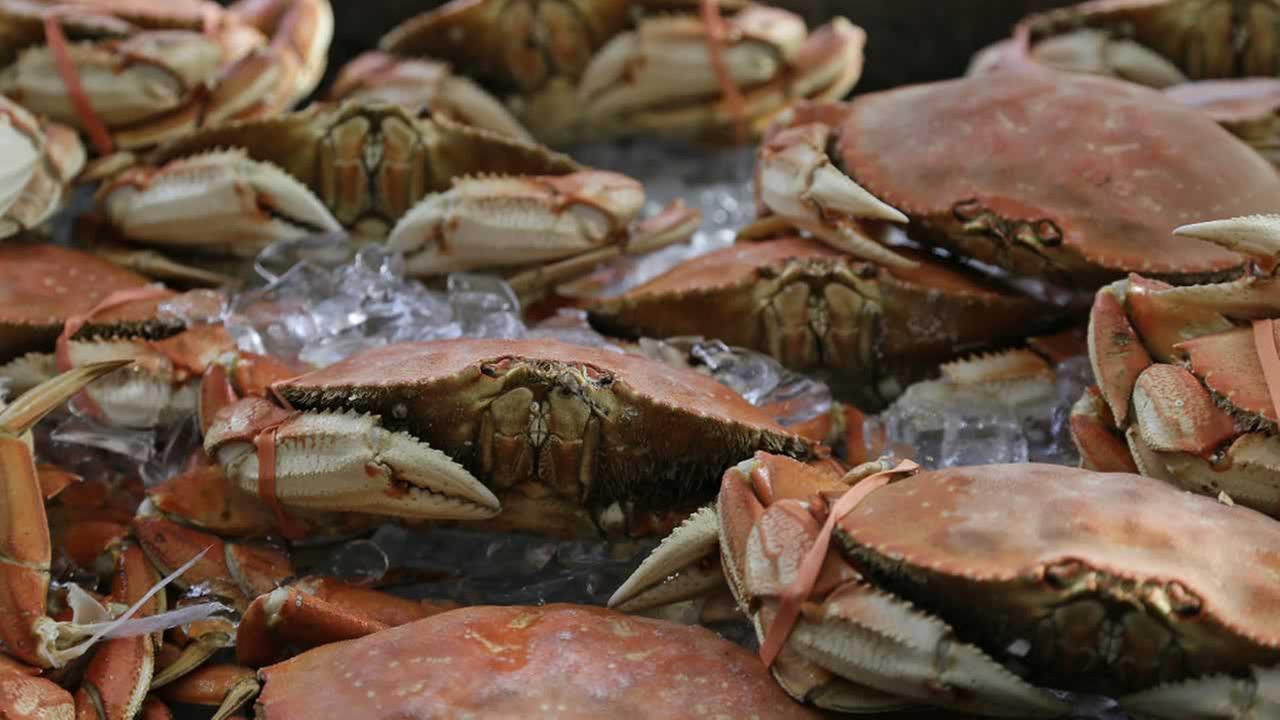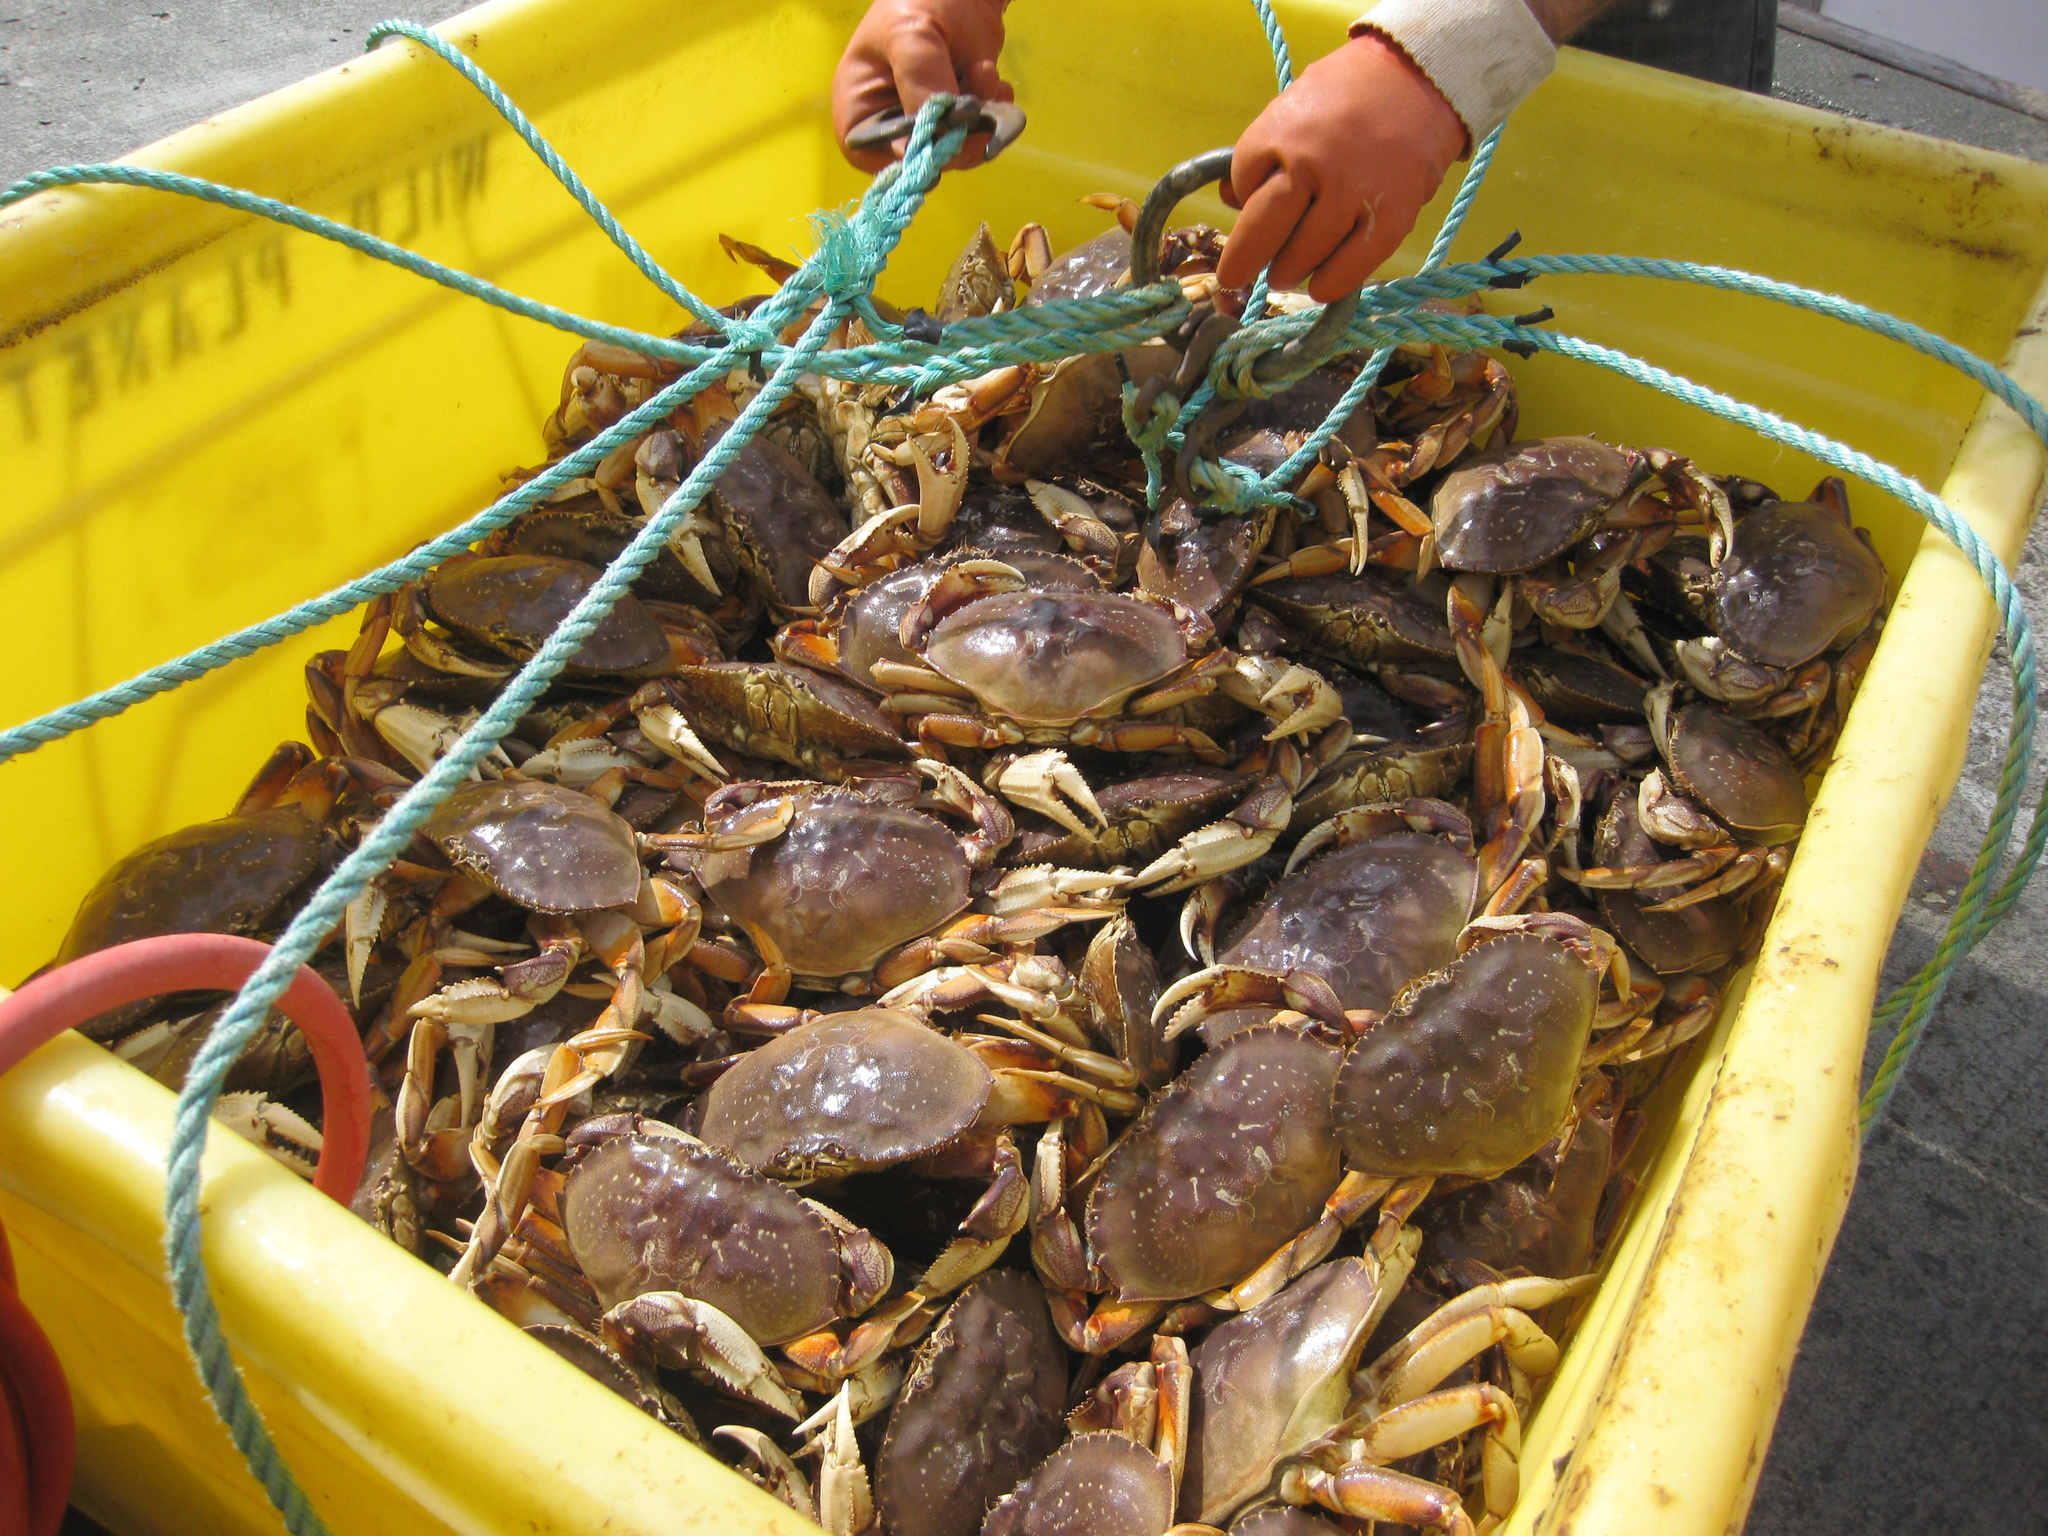The first image is the image on the left, the second image is the image on the right. Given the left and right images, does the statement "There are cables wrapping around the outside of the crate the crabs are in." hold true? Answer yes or no. Yes. The first image is the image on the left, the second image is the image on the right. Given the left and right images, does the statement "The crabs in the image on the right are sitting in a brightly colored container." hold true? Answer yes or no. Yes. 